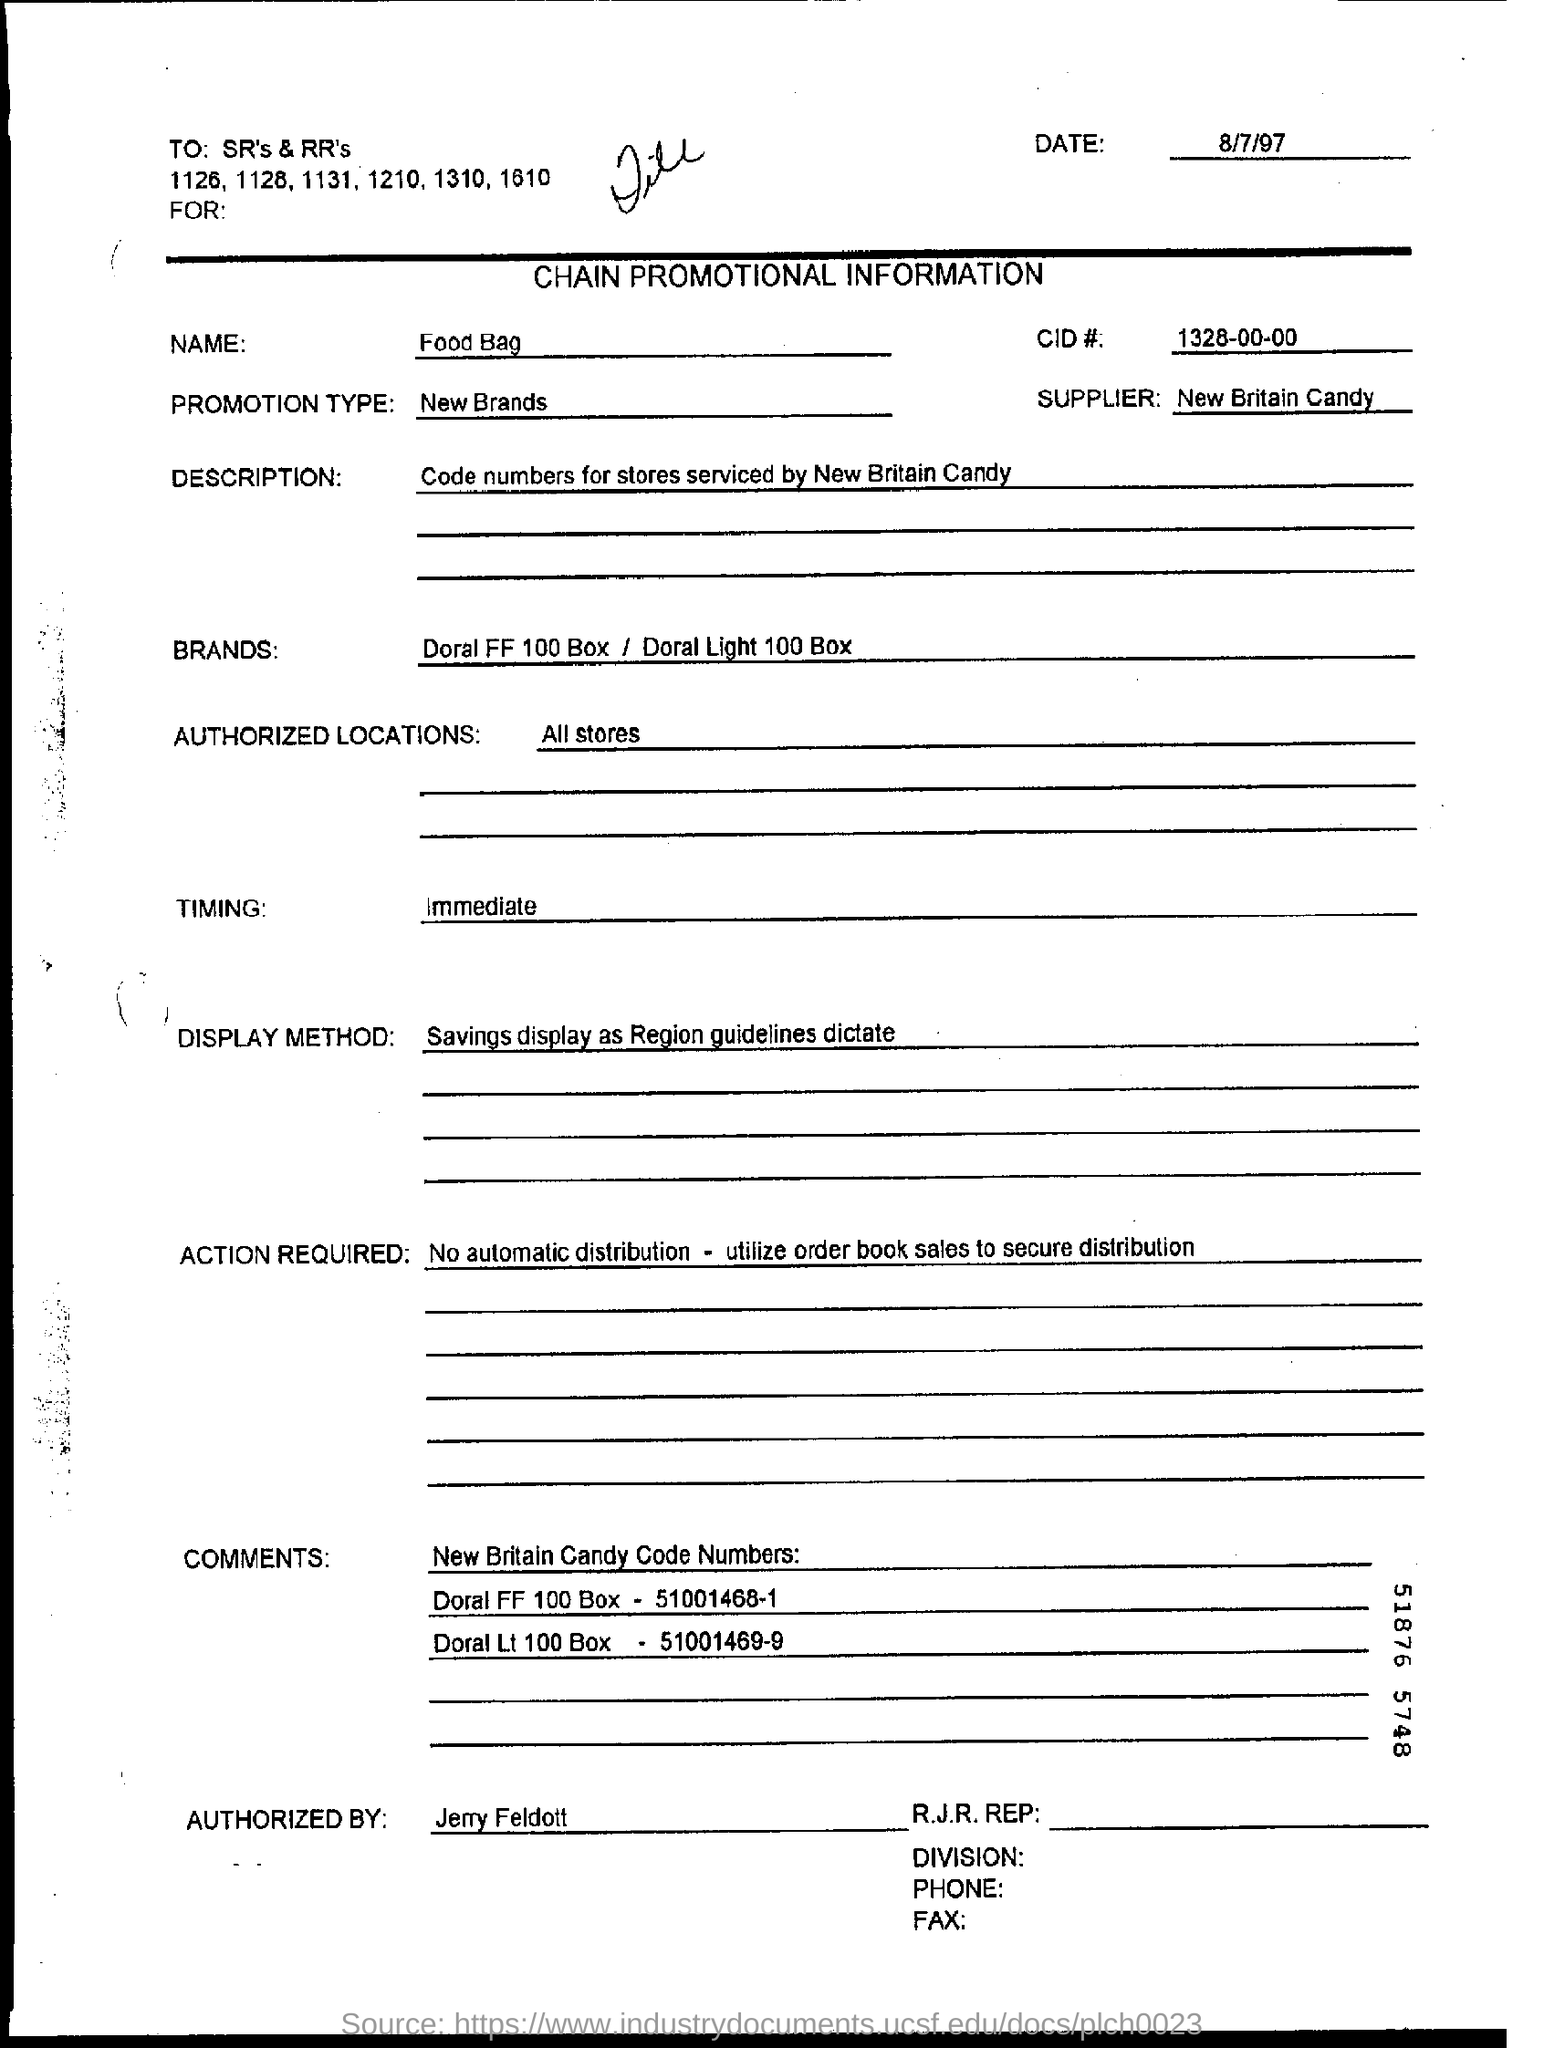Highlight a few significant elements in this photo. The document specifies that all stores are authorized locations. What is the CID# mentioned in the document? It is 1328-00-00. The promotion type given is 'New Brands.' The display method is based on the region guidelines as per the document. The supplier referred to in the text is New Britain Candy. 